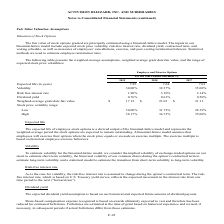According to Activision Blizzard's financial document, How was the fair value of stock options granted estimated by? using a binomial-lattice model.. The document states: "of stock options granted are principally estimated using a binomial-lattice model. The inputs in our..." Also, What was the expected life (in years) for 2019? According to the financial document, 7.85. The relevant text states: "Expected life (in years) 7.85 7.64 7.01..." Also, What was the volatility in 2018? According to the financial document, 32.37%. The relevant text states: "Volatility 30.00% 32.37% 35.00%..." Also, can you calculate: What was the change in volatility between 2018 and 2019? Based on the calculation: 30.00%-32.37%, the result is -2.37 (percentage). This is based on the information: "Volatility 30.00% 32.37% 35.00% Volatility 30.00% 32.37% 35.00%..." The key data points involved are: 30.00, 32.37. Also, can you calculate: What was the change in risk free interest rate between 2017 and 2018? Based on the calculation: 3.10%-2.14%, the result is 0.96 (percentage). This is based on the information: "Risk free interest rate 1.90% 3.10% 2.14% Risk free interest rate 1.90% 3.10% 2.14%..." The key data points involved are: 2.14, 3.10. Also, can you calculate: What was the percentage change in the weighted-average grant date fair value between 2018 and 2019? To answer this question, I need to perform calculations using the financial data. The calculation is: ($17.12-$21.03)/$21.03, which equals -18.59 (percentage). This is based on the information: "Weighted-average grant date fair value $ 17.12 $ 21.03 $ 21.11 Weighted-average grant date fair value $ 17.12 $ 21.03 $ 21.11..." The key data points involved are: 17.12, 21.03. 